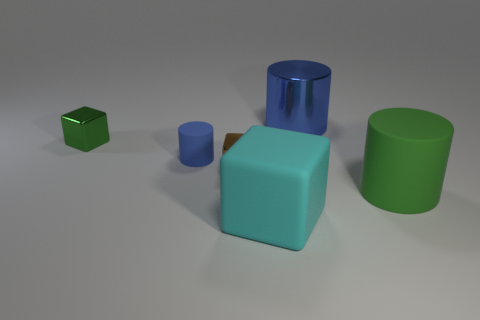What materials are the objects in the image likely made of? The objects appear to be rendered with different materials. The large cylinder seems to have a metallic finish, indicating it might represent a metal material. The cube and the smaller cylinder have a matte finish, which could suggest a plastic or painted wood material. The larger cube has a finish that hints at a possible glass or shiny plastic material. 